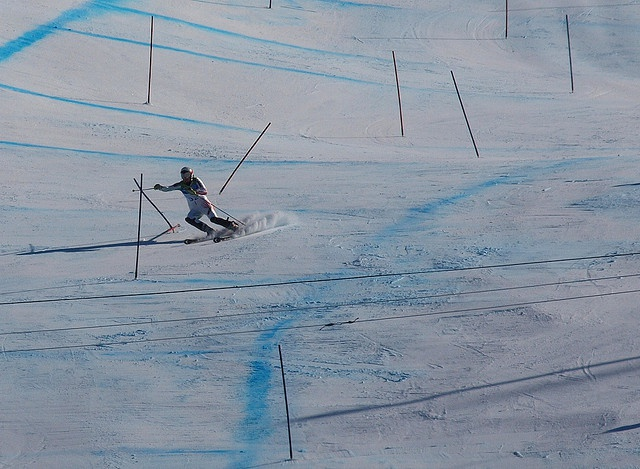Describe the objects in this image and their specific colors. I can see people in darkgray, black, gray, navy, and darkblue tones and skis in darkgray, black, and gray tones in this image. 